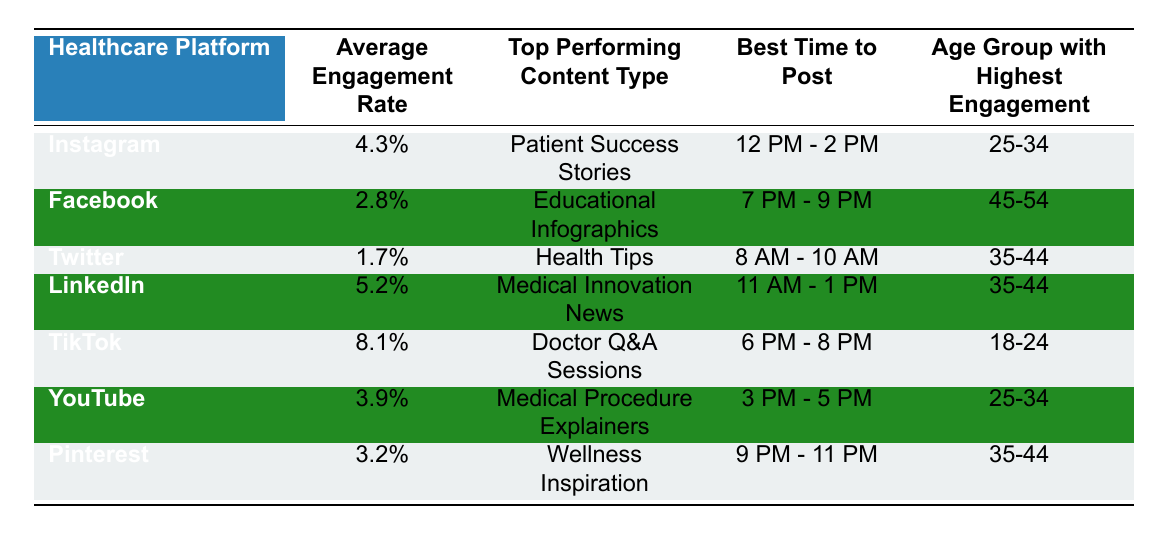What is the average engagement rate on TikTok? The table shows the average engagement rate for TikTok as 8.1%.
Answer: 8.1% Which healthcare platform has the highest engagement rate? The platform with the highest engagement rate is TikTok at 8.1%.
Answer: TikTok What type of content performs best on LinkedIn? According to the table, the top performing content type on LinkedIn is Medical Innovation News.
Answer: Medical Innovation News What is the best time to post on Facebook? The table states the best time to post on Facebook is between 7 PM and 9 PM.
Answer: 7 PM - 9 PM Is the age group with the highest engagement on YouTube the same as on Instagram? The age group with the highest engagement on YouTube is 25-34, while on Instagram it is also 25-34, so the statement is true.
Answer: Yes What is the difference in average engagement rates between LinkedIn and Twitter? LinkedIn has an average engagement rate of 5.2%, while Twitter's is 1.7%. The difference is calculated as 5.2% - 1.7% = 3.5%.
Answer: 3.5% Which content type tends to engage users the most on Instagram? The top performing content type on Instagram is Patient Success Stories as per the table.
Answer: Patient Success Stories Which platform should a healthcare provider post on if they want to reach the 18-24 age group? The platform that engages the 18-24 age group the most is TikTok.
Answer: TikTok How does the average engagement rate for Pinterest compare to Facebook? Pinterest has an engagement rate of 3.2% and Facebook has 2.8%. Comparing these, Pinterest's engagement rate (3.2%) is higher than Facebook's (2.8%) by 0.4%.
Answer: Higher by 0.4% What platform has the best engagement rate and what type of content is recommended for posting? TikTok has the best engagement rate at 8.1%, with the recommended content type being Doctor Q&A Sessions.
Answer: TikTok; Doctor Q&A Sessions 